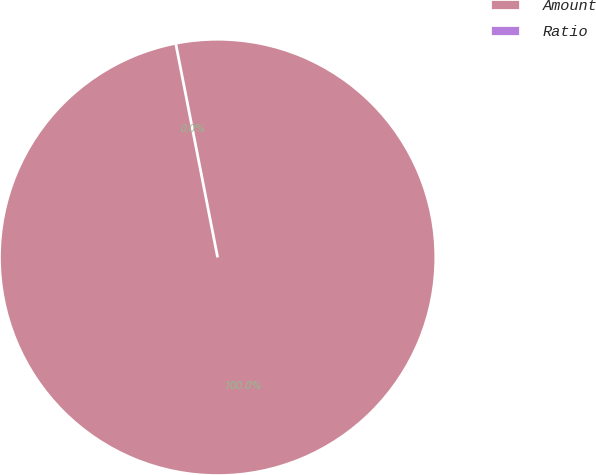<chart> <loc_0><loc_0><loc_500><loc_500><pie_chart><fcel>Amount<fcel>Ratio<nl><fcel>100.0%<fcel>0.0%<nl></chart> 